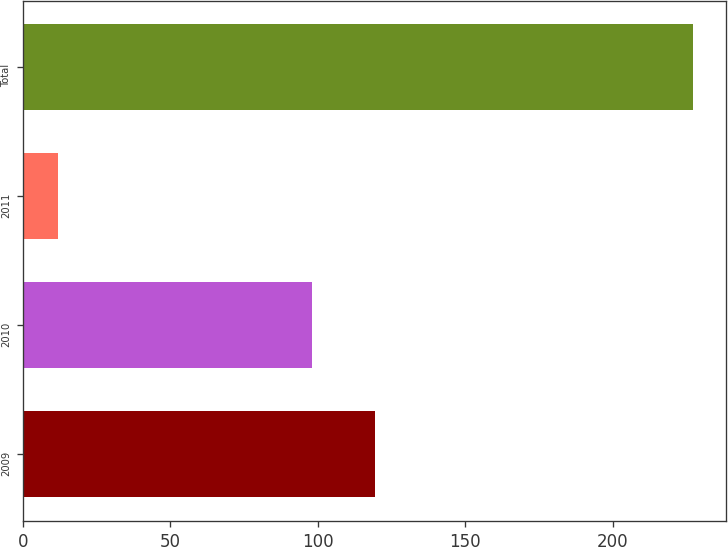<chart> <loc_0><loc_0><loc_500><loc_500><bar_chart><fcel>2009<fcel>2010<fcel>2011<fcel>Total<nl><fcel>119.5<fcel>98<fcel>12<fcel>227<nl></chart> 